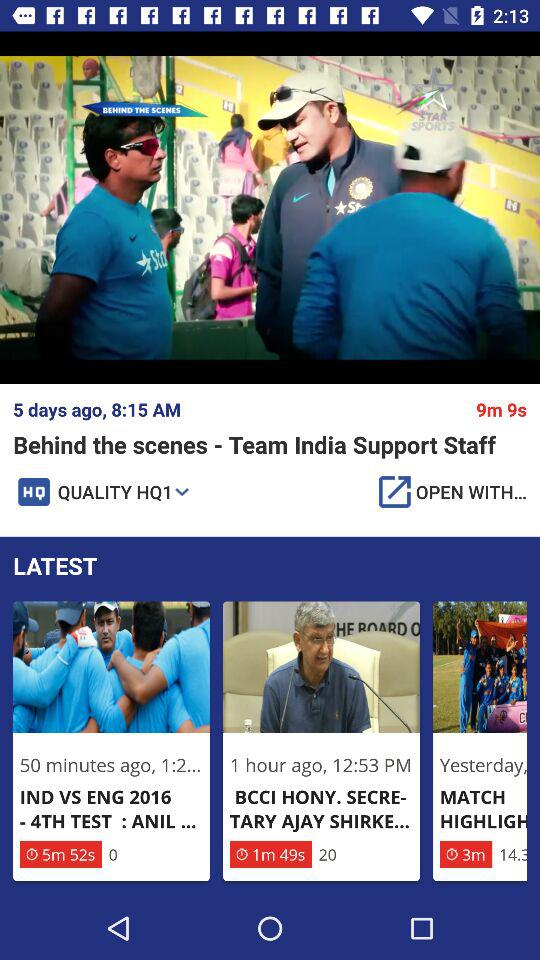What is the video quality? The video quality is HQ1. 